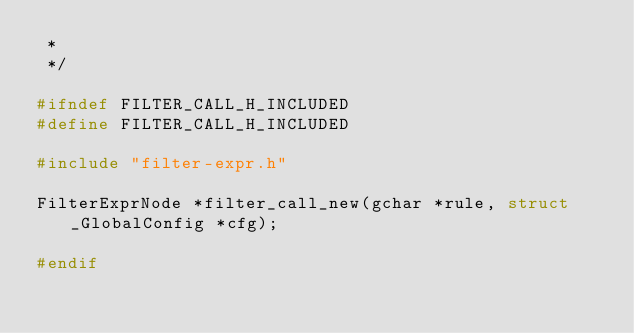Convert code to text. <code><loc_0><loc_0><loc_500><loc_500><_C_> *
 */

#ifndef FILTER_CALL_H_INCLUDED
#define FILTER_CALL_H_INCLUDED

#include "filter-expr.h"

FilterExprNode *filter_call_new(gchar *rule, struct _GlobalConfig *cfg);

#endif
</code> 